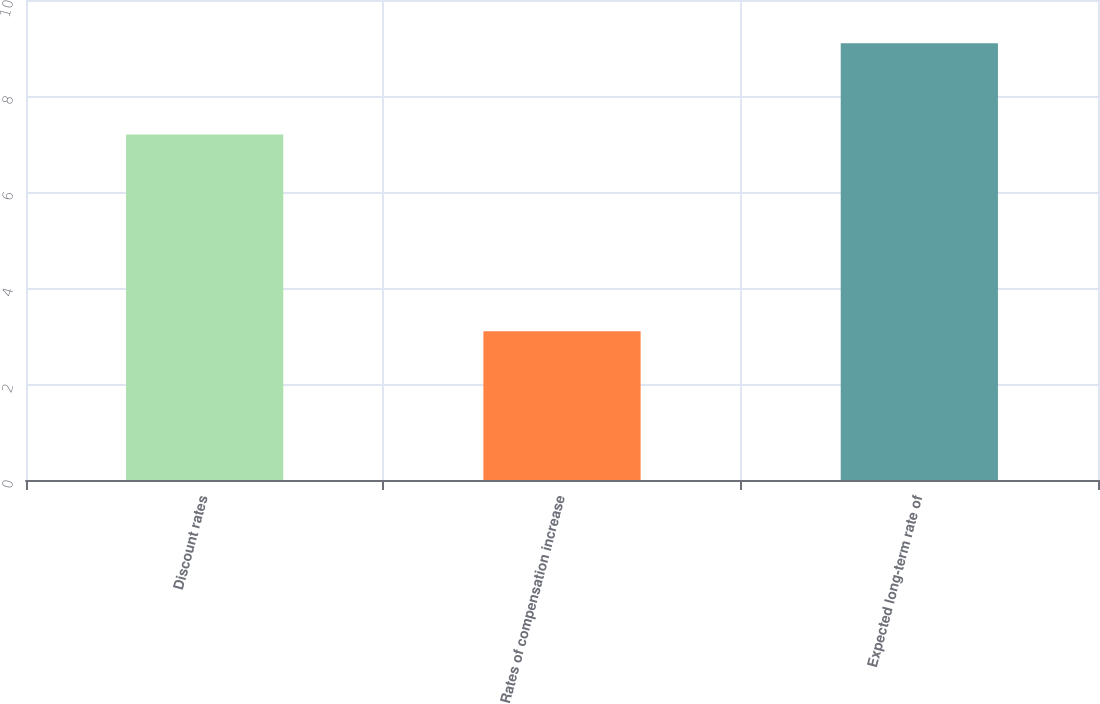Convert chart. <chart><loc_0><loc_0><loc_500><loc_500><bar_chart><fcel>Discount rates<fcel>Rates of compensation increase<fcel>Expected long-term rate of<nl><fcel>7.2<fcel>3.1<fcel>9.1<nl></chart> 